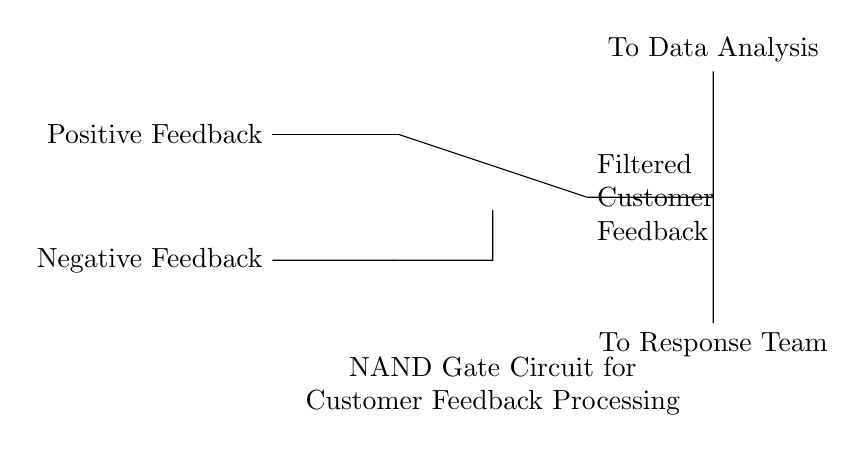What are the inputs for the NAND gate? The inputs are positive feedback and negative feedback, as indicated by the nodes labeled on the left side of the diagram.
Answer: Positive Feedback, Negative Feedback What does the output represent in this circuit? The output labeled "Filtered Customer Feedback" indicates that it processes the inputs to categorize customer feedback efficiently.
Answer: Filtered Customer Feedback Which team receives the output directly? The "Response Team" receives the output as shown in the circuit diagram, which indicates where the output connects below.
Answer: Response Team What happens to the feedback if both inputs are positive? If both inputs are positive, the NAND gate output will be low (or false), meaning it will not pass through to the output channels (Data Analysis or Response Team).
Answer: No output How many pathways are there from the NAND gate output? There are two pathways from the NAND gate output: one leading to Data Analysis and the other to the Response Team.
Answer: Two pathways What type of gate is used in this circuit? The type of gate used is a NAND gate, as explicitly noted in the circuit diagram.
Answer: NAND gate What is the primary function of this circuit? The primary function of the circuit is to filter and categorize customer feedback based on the combination of positive and negative inputs.
Answer: Filtering customer feedback 